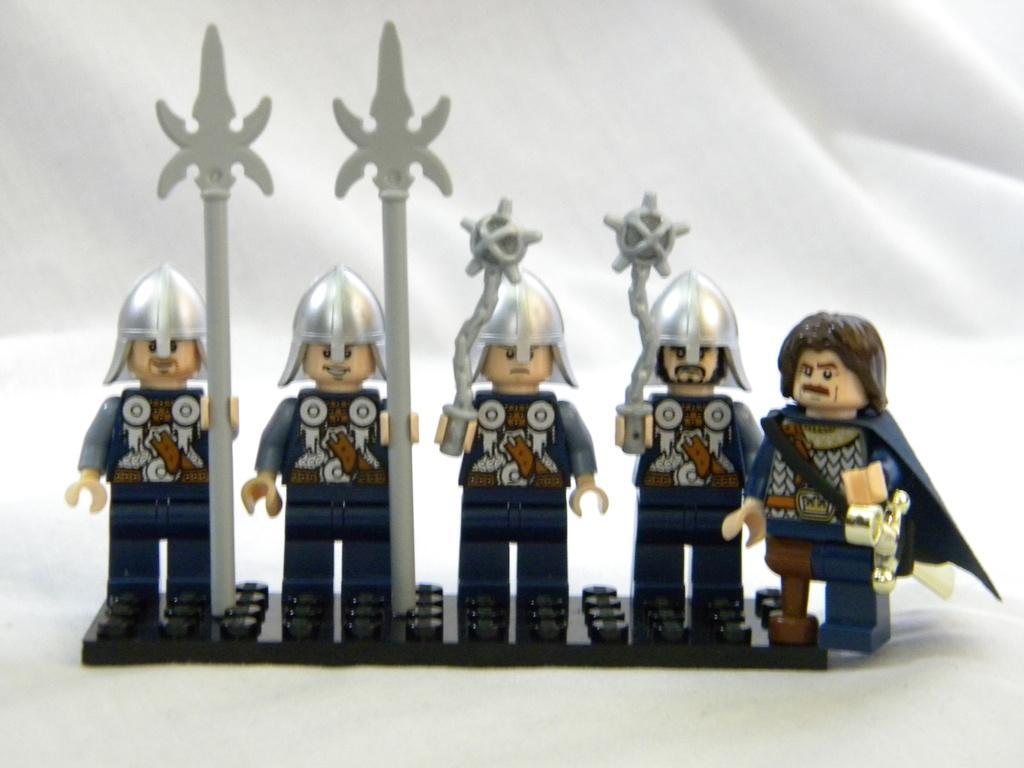In one or two sentences, can you explain what this image depicts? In the image we can see the toys on the white clothes. 